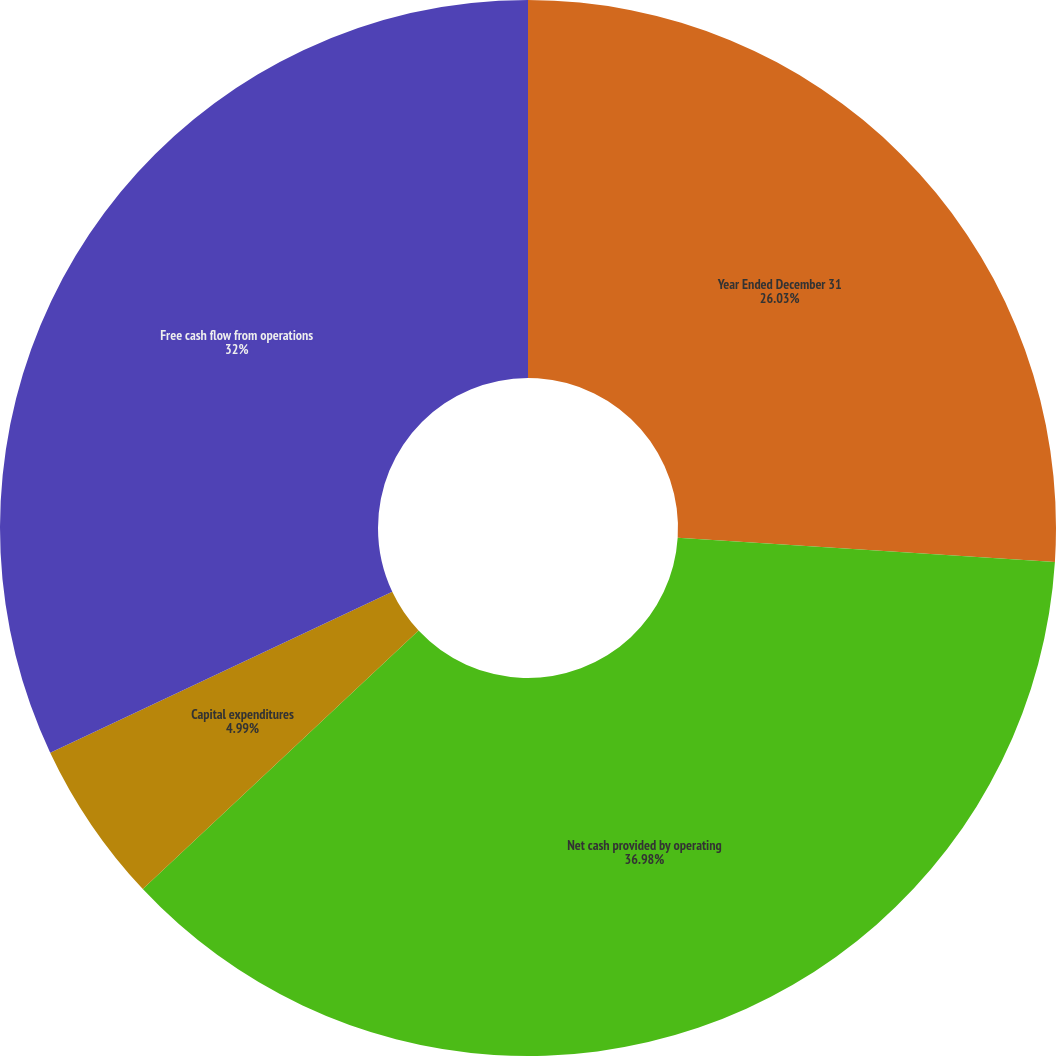Convert chart. <chart><loc_0><loc_0><loc_500><loc_500><pie_chart><fcel>Year Ended December 31<fcel>Net cash provided by operating<fcel>Capital expenditures<fcel>Free cash flow from operations<nl><fcel>26.03%<fcel>36.99%<fcel>4.99%<fcel>32.0%<nl></chart> 